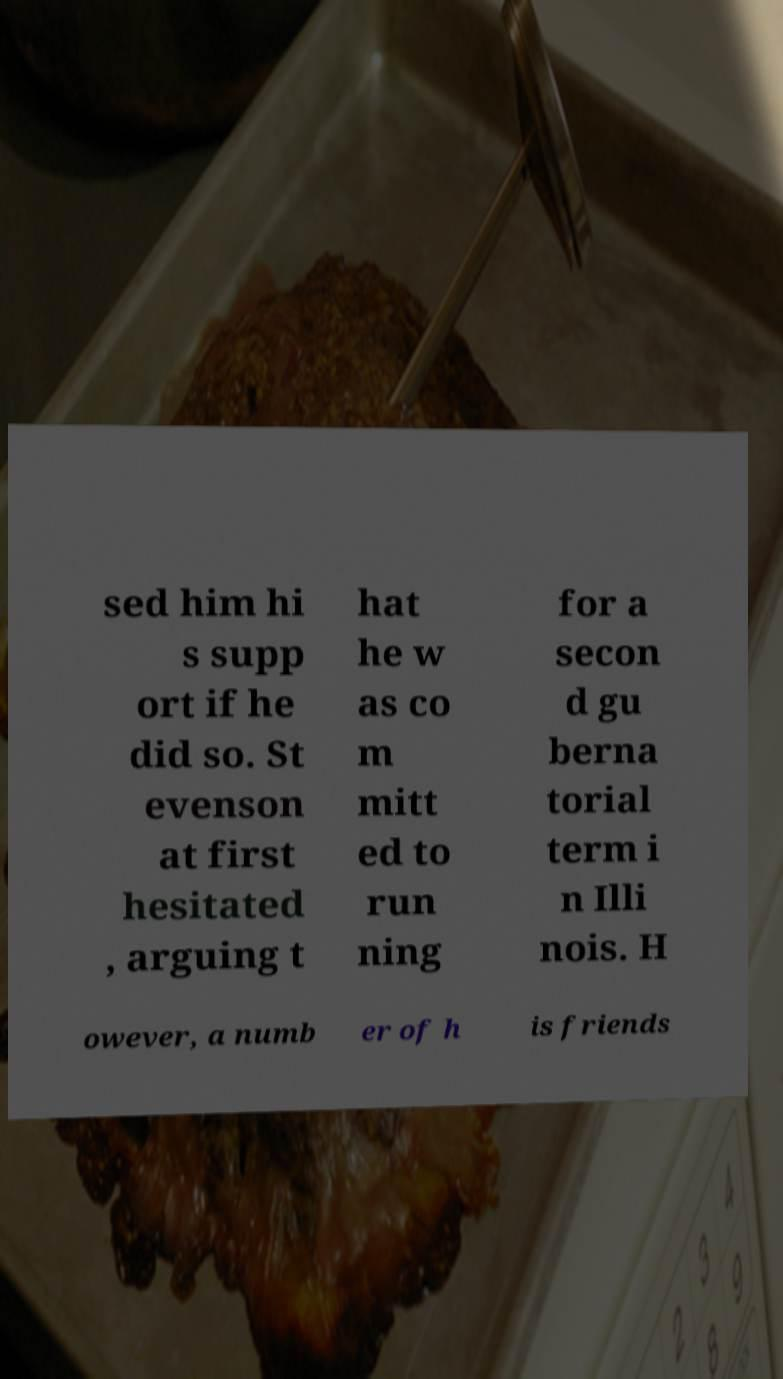Can you accurately transcribe the text from the provided image for me? sed him hi s supp ort if he did so. St evenson at first hesitated , arguing t hat he w as co m mitt ed to run ning for a secon d gu berna torial term i n Illi nois. H owever, a numb er of h is friends 